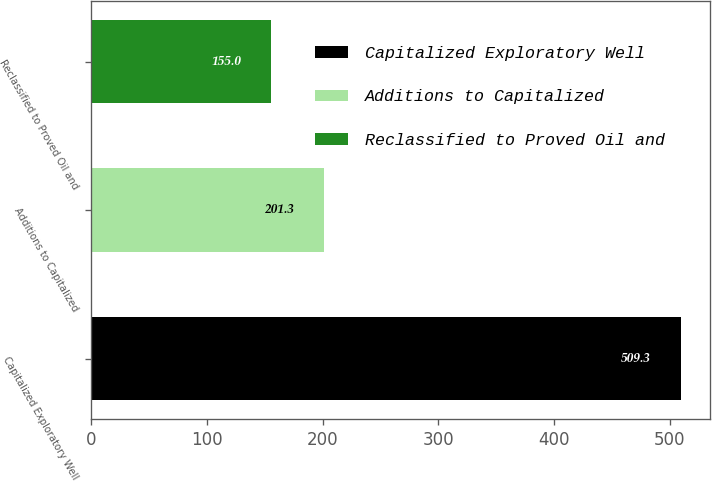Convert chart. <chart><loc_0><loc_0><loc_500><loc_500><bar_chart><fcel>Capitalized Exploratory Well<fcel>Additions to Capitalized<fcel>Reclassified to Proved Oil and<nl><fcel>509.3<fcel>201.3<fcel>155<nl></chart> 